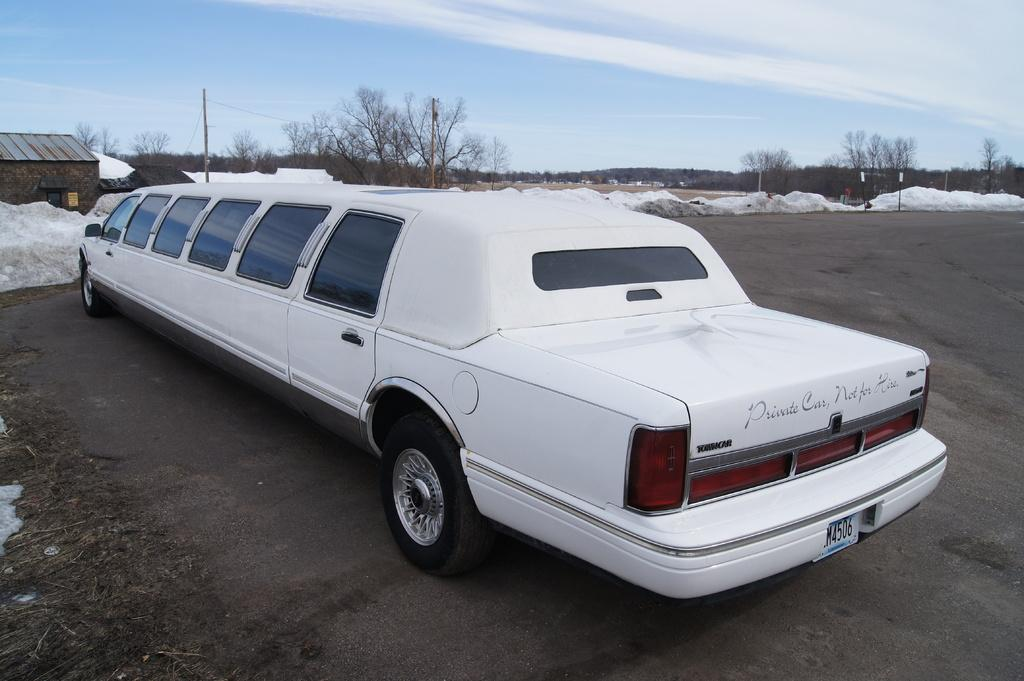What type of vehicle is in the image? There is a white limousine car in the image. Where is the car located? The car is on a road. What can be seen in the background of the image? There is a house, snow, trees, and a clear sky visible in the background. What type of division can be seen in the image? There is no division present in the image; it features a white limousine car on a road with a background of a house, snow, trees, and a clear sky. What is the car using to cut through the snow in the image? There is no car cutting through snow in the image, and there are no scissors present. 